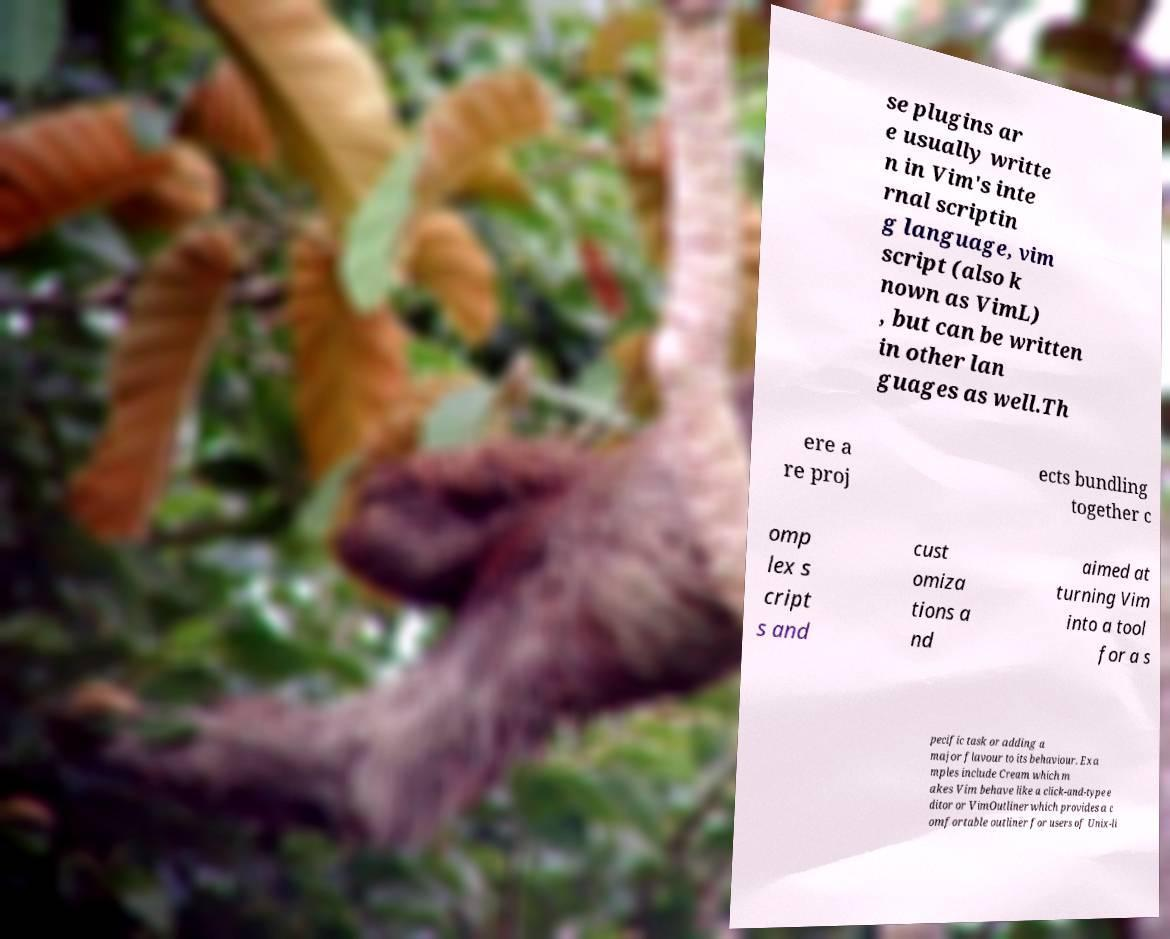Can you read and provide the text displayed in the image?This photo seems to have some interesting text. Can you extract and type it out for me? se plugins ar e usually writte n in Vim's inte rnal scriptin g language, vim script (also k nown as VimL) , but can be written in other lan guages as well.Th ere a re proj ects bundling together c omp lex s cript s and cust omiza tions a nd aimed at turning Vim into a tool for a s pecific task or adding a major flavour to its behaviour. Exa mples include Cream which m akes Vim behave like a click-and-type e ditor or VimOutliner which provides a c omfortable outliner for users of Unix-li 